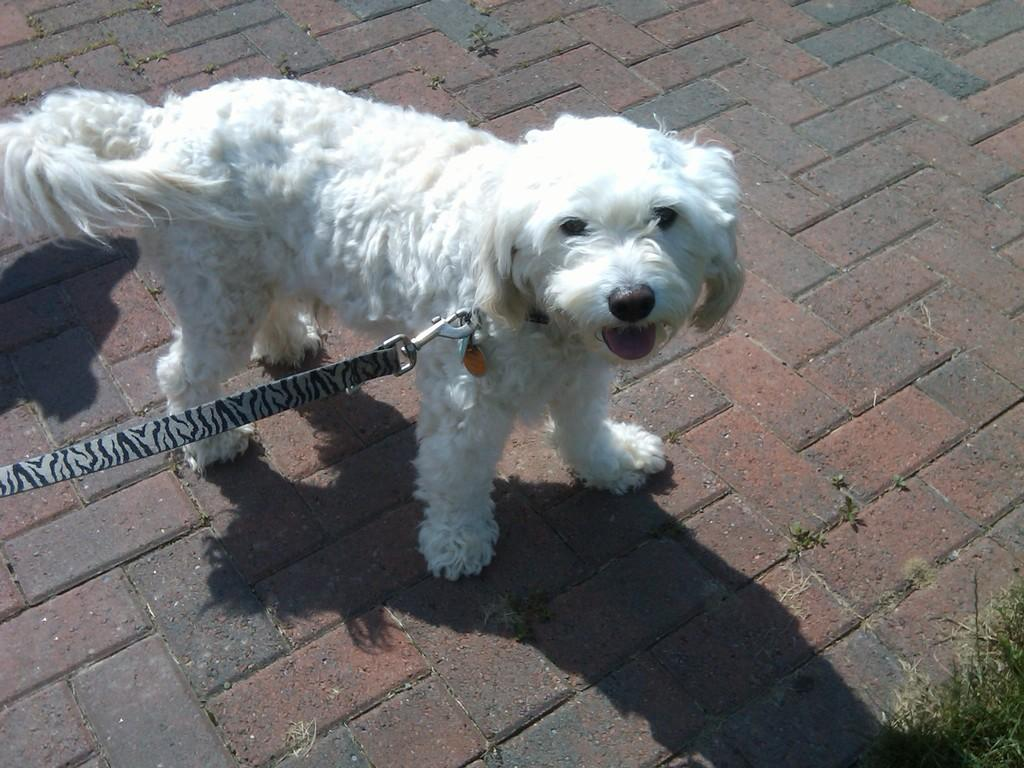What type of animal is in the image? There is a white dog in the image. What is the dog wearing? The dog is wearing a belt. Where is the dog standing? The dog is standing on the floor. What type of vegetation can be seen in the image? There is grass in the bottom right corner of the image. What type of wheel is the girl using to transport the dog in the image? There is no girl or wheel present in the image; it features a white dog wearing a belt and standing on the floor. 